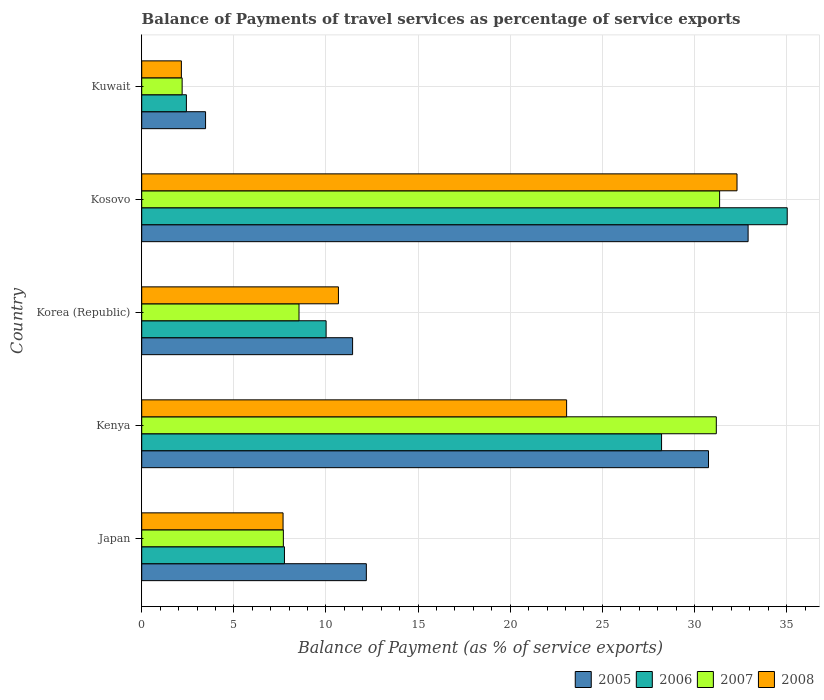How many groups of bars are there?
Offer a very short reply. 5. What is the label of the 2nd group of bars from the top?
Offer a terse response. Kosovo. What is the balance of payments of travel services in 2008 in Korea (Republic)?
Your answer should be compact. 10.68. Across all countries, what is the maximum balance of payments of travel services in 2008?
Offer a very short reply. 32.31. Across all countries, what is the minimum balance of payments of travel services in 2005?
Make the answer very short. 3.46. In which country was the balance of payments of travel services in 2006 maximum?
Offer a terse response. Kosovo. In which country was the balance of payments of travel services in 2005 minimum?
Ensure brevity in your answer.  Kuwait. What is the total balance of payments of travel services in 2006 in the graph?
Your answer should be very brief. 83.42. What is the difference between the balance of payments of travel services in 2008 in Kenya and that in Kuwait?
Your response must be concise. 20.91. What is the difference between the balance of payments of travel services in 2005 in Japan and the balance of payments of travel services in 2006 in Korea (Republic)?
Keep it short and to the point. 2.18. What is the average balance of payments of travel services in 2008 per country?
Provide a short and direct response. 15.17. What is the difference between the balance of payments of travel services in 2006 and balance of payments of travel services in 2005 in Korea (Republic)?
Give a very brief answer. -1.44. In how many countries, is the balance of payments of travel services in 2006 greater than 28 %?
Your answer should be compact. 2. What is the ratio of the balance of payments of travel services in 2006 in Kenya to that in Kuwait?
Offer a terse response. 11.64. Is the difference between the balance of payments of travel services in 2006 in Japan and Kuwait greater than the difference between the balance of payments of travel services in 2005 in Japan and Kuwait?
Offer a terse response. No. What is the difference between the highest and the second highest balance of payments of travel services in 2006?
Give a very brief answer. 6.82. What is the difference between the highest and the lowest balance of payments of travel services in 2005?
Keep it short and to the point. 29.45. Is the sum of the balance of payments of travel services in 2005 in Japan and Kuwait greater than the maximum balance of payments of travel services in 2007 across all countries?
Your answer should be very brief. No. Is it the case that in every country, the sum of the balance of payments of travel services in 2008 and balance of payments of travel services in 2007 is greater than the sum of balance of payments of travel services in 2006 and balance of payments of travel services in 2005?
Your response must be concise. No. Is it the case that in every country, the sum of the balance of payments of travel services in 2005 and balance of payments of travel services in 2006 is greater than the balance of payments of travel services in 2007?
Make the answer very short. Yes. Are all the bars in the graph horizontal?
Offer a terse response. Yes. How many countries are there in the graph?
Offer a terse response. 5. Are the values on the major ticks of X-axis written in scientific E-notation?
Offer a terse response. No. Does the graph contain any zero values?
Your answer should be compact. No. Does the graph contain grids?
Provide a succinct answer. Yes. Where does the legend appear in the graph?
Provide a short and direct response. Bottom right. What is the title of the graph?
Offer a very short reply. Balance of Payments of travel services as percentage of service exports. Does "2001" appear as one of the legend labels in the graph?
Keep it short and to the point. No. What is the label or title of the X-axis?
Your response must be concise. Balance of Payment (as % of service exports). What is the label or title of the Y-axis?
Your answer should be compact. Country. What is the Balance of Payment (as % of service exports) in 2005 in Japan?
Offer a very short reply. 12.19. What is the Balance of Payment (as % of service exports) of 2006 in Japan?
Your answer should be very brief. 7.75. What is the Balance of Payment (as % of service exports) of 2007 in Japan?
Ensure brevity in your answer.  7.69. What is the Balance of Payment (as % of service exports) of 2008 in Japan?
Give a very brief answer. 7.67. What is the Balance of Payment (as % of service exports) in 2005 in Kenya?
Make the answer very short. 30.76. What is the Balance of Payment (as % of service exports) of 2006 in Kenya?
Ensure brevity in your answer.  28.21. What is the Balance of Payment (as % of service exports) in 2007 in Kenya?
Make the answer very short. 31.18. What is the Balance of Payment (as % of service exports) of 2008 in Kenya?
Ensure brevity in your answer.  23.06. What is the Balance of Payment (as % of service exports) of 2005 in Korea (Republic)?
Provide a short and direct response. 11.44. What is the Balance of Payment (as % of service exports) in 2006 in Korea (Republic)?
Make the answer very short. 10.01. What is the Balance of Payment (as % of service exports) in 2007 in Korea (Republic)?
Provide a short and direct response. 8.54. What is the Balance of Payment (as % of service exports) of 2008 in Korea (Republic)?
Make the answer very short. 10.68. What is the Balance of Payment (as % of service exports) of 2005 in Kosovo?
Provide a short and direct response. 32.91. What is the Balance of Payment (as % of service exports) of 2006 in Kosovo?
Provide a short and direct response. 35.03. What is the Balance of Payment (as % of service exports) in 2007 in Kosovo?
Provide a short and direct response. 31.36. What is the Balance of Payment (as % of service exports) of 2008 in Kosovo?
Provide a succinct answer. 32.31. What is the Balance of Payment (as % of service exports) of 2005 in Kuwait?
Your answer should be very brief. 3.46. What is the Balance of Payment (as % of service exports) of 2006 in Kuwait?
Ensure brevity in your answer.  2.42. What is the Balance of Payment (as % of service exports) in 2007 in Kuwait?
Your answer should be compact. 2.19. What is the Balance of Payment (as % of service exports) in 2008 in Kuwait?
Your answer should be very brief. 2.15. Across all countries, what is the maximum Balance of Payment (as % of service exports) in 2005?
Your response must be concise. 32.91. Across all countries, what is the maximum Balance of Payment (as % of service exports) in 2006?
Offer a terse response. 35.03. Across all countries, what is the maximum Balance of Payment (as % of service exports) of 2007?
Make the answer very short. 31.36. Across all countries, what is the maximum Balance of Payment (as % of service exports) of 2008?
Offer a terse response. 32.31. Across all countries, what is the minimum Balance of Payment (as % of service exports) in 2005?
Keep it short and to the point. 3.46. Across all countries, what is the minimum Balance of Payment (as % of service exports) in 2006?
Provide a succinct answer. 2.42. Across all countries, what is the minimum Balance of Payment (as % of service exports) of 2007?
Offer a terse response. 2.19. Across all countries, what is the minimum Balance of Payment (as % of service exports) in 2008?
Offer a terse response. 2.15. What is the total Balance of Payment (as % of service exports) of 2005 in the graph?
Your answer should be very brief. 90.77. What is the total Balance of Payment (as % of service exports) of 2006 in the graph?
Offer a terse response. 83.42. What is the total Balance of Payment (as % of service exports) of 2007 in the graph?
Provide a succinct answer. 80.96. What is the total Balance of Payment (as % of service exports) in 2008 in the graph?
Your answer should be compact. 75.87. What is the difference between the Balance of Payment (as % of service exports) of 2005 in Japan and that in Kenya?
Offer a terse response. -18.57. What is the difference between the Balance of Payment (as % of service exports) of 2006 in Japan and that in Kenya?
Provide a succinct answer. -20.47. What is the difference between the Balance of Payment (as % of service exports) of 2007 in Japan and that in Kenya?
Offer a terse response. -23.5. What is the difference between the Balance of Payment (as % of service exports) in 2008 in Japan and that in Kenya?
Offer a very short reply. -15.39. What is the difference between the Balance of Payment (as % of service exports) in 2005 in Japan and that in Korea (Republic)?
Offer a very short reply. 0.75. What is the difference between the Balance of Payment (as % of service exports) of 2006 in Japan and that in Korea (Republic)?
Keep it short and to the point. -2.26. What is the difference between the Balance of Payment (as % of service exports) in 2007 in Japan and that in Korea (Republic)?
Your answer should be very brief. -0.85. What is the difference between the Balance of Payment (as % of service exports) in 2008 in Japan and that in Korea (Republic)?
Offer a terse response. -3. What is the difference between the Balance of Payment (as % of service exports) in 2005 in Japan and that in Kosovo?
Your answer should be compact. -20.72. What is the difference between the Balance of Payment (as % of service exports) in 2006 in Japan and that in Kosovo?
Keep it short and to the point. -27.29. What is the difference between the Balance of Payment (as % of service exports) in 2007 in Japan and that in Kosovo?
Provide a succinct answer. -23.68. What is the difference between the Balance of Payment (as % of service exports) in 2008 in Japan and that in Kosovo?
Make the answer very short. -24.64. What is the difference between the Balance of Payment (as % of service exports) in 2005 in Japan and that in Kuwait?
Keep it short and to the point. 8.73. What is the difference between the Balance of Payment (as % of service exports) of 2006 in Japan and that in Kuwait?
Make the answer very short. 5.32. What is the difference between the Balance of Payment (as % of service exports) in 2007 in Japan and that in Kuwait?
Your answer should be very brief. 5.49. What is the difference between the Balance of Payment (as % of service exports) in 2008 in Japan and that in Kuwait?
Provide a short and direct response. 5.52. What is the difference between the Balance of Payment (as % of service exports) of 2005 in Kenya and that in Korea (Republic)?
Your response must be concise. 19.32. What is the difference between the Balance of Payment (as % of service exports) in 2006 in Kenya and that in Korea (Republic)?
Keep it short and to the point. 18.21. What is the difference between the Balance of Payment (as % of service exports) of 2007 in Kenya and that in Korea (Republic)?
Your answer should be very brief. 22.65. What is the difference between the Balance of Payment (as % of service exports) in 2008 in Kenya and that in Korea (Republic)?
Give a very brief answer. 12.38. What is the difference between the Balance of Payment (as % of service exports) in 2005 in Kenya and that in Kosovo?
Your response must be concise. -2.15. What is the difference between the Balance of Payment (as % of service exports) in 2006 in Kenya and that in Kosovo?
Your response must be concise. -6.82. What is the difference between the Balance of Payment (as % of service exports) of 2007 in Kenya and that in Kosovo?
Provide a short and direct response. -0.18. What is the difference between the Balance of Payment (as % of service exports) in 2008 in Kenya and that in Kosovo?
Offer a very short reply. -9.25. What is the difference between the Balance of Payment (as % of service exports) in 2005 in Kenya and that in Kuwait?
Provide a short and direct response. 27.3. What is the difference between the Balance of Payment (as % of service exports) in 2006 in Kenya and that in Kuwait?
Ensure brevity in your answer.  25.79. What is the difference between the Balance of Payment (as % of service exports) of 2007 in Kenya and that in Kuwait?
Your answer should be compact. 28.99. What is the difference between the Balance of Payment (as % of service exports) in 2008 in Kenya and that in Kuwait?
Your answer should be very brief. 20.91. What is the difference between the Balance of Payment (as % of service exports) in 2005 in Korea (Republic) and that in Kosovo?
Keep it short and to the point. -21.47. What is the difference between the Balance of Payment (as % of service exports) of 2006 in Korea (Republic) and that in Kosovo?
Give a very brief answer. -25.03. What is the difference between the Balance of Payment (as % of service exports) of 2007 in Korea (Republic) and that in Kosovo?
Your answer should be very brief. -22.83. What is the difference between the Balance of Payment (as % of service exports) in 2008 in Korea (Republic) and that in Kosovo?
Provide a succinct answer. -21.63. What is the difference between the Balance of Payment (as % of service exports) of 2005 in Korea (Republic) and that in Kuwait?
Keep it short and to the point. 7.98. What is the difference between the Balance of Payment (as % of service exports) in 2006 in Korea (Republic) and that in Kuwait?
Your answer should be very brief. 7.58. What is the difference between the Balance of Payment (as % of service exports) of 2007 in Korea (Republic) and that in Kuwait?
Provide a short and direct response. 6.34. What is the difference between the Balance of Payment (as % of service exports) in 2008 in Korea (Republic) and that in Kuwait?
Provide a succinct answer. 8.52. What is the difference between the Balance of Payment (as % of service exports) of 2005 in Kosovo and that in Kuwait?
Ensure brevity in your answer.  29.45. What is the difference between the Balance of Payment (as % of service exports) of 2006 in Kosovo and that in Kuwait?
Give a very brief answer. 32.61. What is the difference between the Balance of Payment (as % of service exports) of 2007 in Kosovo and that in Kuwait?
Make the answer very short. 29.17. What is the difference between the Balance of Payment (as % of service exports) in 2008 in Kosovo and that in Kuwait?
Offer a very short reply. 30.16. What is the difference between the Balance of Payment (as % of service exports) in 2005 in Japan and the Balance of Payment (as % of service exports) in 2006 in Kenya?
Your answer should be compact. -16.02. What is the difference between the Balance of Payment (as % of service exports) in 2005 in Japan and the Balance of Payment (as % of service exports) in 2007 in Kenya?
Your answer should be very brief. -18.99. What is the difference between the Balance of Payment (as % of service exports) of 2005 in Japan and the Balance of Payment (as % of service exports) of 2008 in Kenya?
Provide a short and direct response. -10.87. What is the difference between the Balance of Payment (as % of service exports) in 2006 in Japan and the Balance of Payment (as % of service exports) in 2007 in Kenya?
Your answer should be very brief. -23.44. What is the difference between the Balance of Payment (as % of service exports) in 2006 in Japan and the Balance of Payment (as % of service exports) in 2008 in Kenya?
Provide a short and direct response. -15.31. What is the difference between the Balance of Payment (as % of service exports) of 2007 in Japan and the Balance of Payment (as % of service exports) of 2008 in Kenya?
Your answer should be very brief. -15.37. What is the difference between the Balance of Payment (as % of service exports) of 2005 in Japan and the Balance of Payment (as % of service exports) of 2006 in Korea (Republic)?
Offer a very short reply. 2.18. What is the difference between the Balance of Payment (as % of service exports) of 2005 in Japan and the Balance of Payment (as % of service exports) of 2007 in Korea (Republic)?
Offer a terse response. 3.65. What is the difference between the Balance of Payment (as % of service exports) of 2005 in Japan and the Balance of Payment (as % of service exports) of 2008 in Korea (Republic)?
Your answer should be compact. 1.52. What is the difference between the Balance of Payment (as % of service exports) in 2006 in Japan and the Balance of Payment (as % of service exports) in 2007 in Korea (Republic)?
Keep it short and to the point. -0.79. What is the difference between the Balance of Payment (as % of service exports) of 2006 in Japan and the Balance of Payment (as % of service exports) of 2008 in Korea (Republic)?
Give a very brief answer. -2.93. What is the difference between the Balance of Payment (as % of service exports) in 2007 in Japan and the Balance of Payment (as % of service exports) in 2008 in Korea (Republic)?
Your response must be concise. -2.99. What is the difference between the Balance of Payment (as % of service exports) of 2005 in Japan and the Balance of Payment (as % of service exports) of 2006 in Kosovo?
Your answer should be very brief. -22.84. What is the difference between the Balance of Payment (as % of service exports) of 2005 in Japan and the Balance of Payment (as % of service exports) of 2007 in Kosovo?
Your answer should be compact. -19.17. What is the difference between the Balance of Payment (as % of service exports) in 2005 in Japan and the Balance of Payment (as % of service exports) in 2008 in Kosovo?
Offer a terse response. -20.12. What is the difference between the Balance of Payment (as % of service exports) of 2006 in Japan and the Balance of Payment (as % of service exports) of 2007 in Kosovo?
Your answer should be compact. -23.62. What is the difference between the Balance of Payment (as % of service exports) in 2006 in Japan and the Balance of Payment (as % of service exports) in 2008 in Kosovo?
Provide a succinct answer. -24.56. What is the difference between the Balance of Payment (as % of service exports) of 2007 in Japan and the Balance of Payment (as % of service exports) of 2008 in Kosovo?
Keep it short and to the point. -24.62. What is the difference between the Balance of Payment (as % of service exports) in 2005 in Japan and the Balance of Payment (as % of service exports) in 2006 in Kuwait?
Keep it short and to the point. 9.77. What is the difference between the Balance of Payment (as % of service exports) in 2005 in Japan and the Balance of Payment (as % of service exports) in 2007 in Kuwait?
Make the answer very short. 10. What is the difference between the Balance of Payment (as % of service exports) of 2005 in Japan and the Balance of Payment (as % of service exports) of 2008 in Kuwait?
Offer a very short reply. 10.04. What is the difference between the Balance of Payment (as % of service exports) of 2006 in Japan and the Balance of Payment (as % of service exports) of 2007 in Kuwait?
Give a very brief answer. 5.55. What is the difference between the Balance of Payment (as % of service exports) of 2006 in Japan and the Balance of Payment (as % of service exports) of 2008 in Kuwait?
Your answer should be compact. 5.59. What is the difference between the Balance of Payment (as % of service exports) of 2007 in Japan and the Balance of Payment (as % of service exports) of 2008 in Kuwait?
Your answer should be compact. 5.53. What is the difference between the Balance of Payment (as % of service exports) of 2005 in Kenya and the Balance of Payment (as % of service exports) of 2006 in Korea (Republic)?
Provide a succinct answer. 20.75. What is the difference between the Balance of Payment (as % of service exports) of 2005 in Kenya and the Balance of Payment (as % of service exports) of 2007 in Korea (Republic)?
Your answer should be compact. 22.22. What is the difference between the Balance of Payment (as % of service exports) in 2005 in Kenya and the Balance of Payment (as % of service exports) in 2008 in Korea (Republic)?
Make the answer very short. 20.08. What is the difference between the Balance of Payment (as % of service exports) in 2006 in Kenya and the Balance of Payment (as % of service exports) in 2007 in Korea (Republic)?
Offer a terse response. 19.68. What is the difference between the Balance of Payment (as % of service exports) in 2006 in Kenya and the Balance of Payment (as % of service exports) in 2008 in Korea (Republic)?
Provide a succinct answer. 17.54. What is the difference between the Balance of Payment (as % of service exports) of 2007 in Kenya and the Balance of Payment (as % of service exports) of 2008 in Korea (Republic)?
Ensure brevity in your answer.  20.51. What is the difference between the Balance of Payment (as % of service exports) of 2005 in Kenya and the Balance of Payment (as % of service exports) of 2006 in Kosovo?
Provide a short and direct response. -4.27. What is the difference between the Balance of Payment (as % of service exports) in 2005 in Kenya and the Balance of Payment (as % of service exports) in 2007 in Kosovo?
Keep it short and to the point. -0.6. What is the difference between the Balance of Payment (as % of service exports) of 2005 in Kenya and the Balance of Payment (as % of service exports) of 2008 in Kosovo?
Make the answer very short. -1.55. What is the difference between the Balance of Payment (as % of service exports) of 2006 in Kenya and the Balance of Payment (as % of service exports) of 2007 in Kosovo?
Your answer should be compact. -3.15. What is the difference between the Balance of Payment (as % of service exports) in 2006 in Kenya and the Balance of Payment (as % of service exports) in 2008 in Kosovo?
Provide a short and direct response. -4.09. What is the difference between the Balance of Payment (as % of service exports) in 2007 in Kenya and the Balance of Payment (as % of service exports) in 2008 in Kosovo?
Your answer should be very brief. -1.12. What is the difference between the Balance of Payment (as % of service exports) in 2005 in Kenya and the Balance of Payment (as % of service exports) in 2006 in Kuwait?
Ensure brevity in your answer.  28.34. What is the difference between the Balance of Payment (as % of service exports) of 2005 in Kenya and the Balance of Payment (as % of service exports) of 2007 in Kuwait?
Keep it short and to the point. 28.57. What is the difference between the Balance of Payment (as % of service exports) in 2005 in Kenya and the Balance of Payment (as % of service exports) in 2008 in Kuwait?
Offer a terse response. 28.61. What is the difference between the Balance of Payment (as % of service exports) in 2006 in Kenya and the Balance of Payment (as % of service exports) in 2007 in Kuwait?
Give a very brief answer. 26.02. What is the difference between the Balance of Payment (as % of service exports) in 2006 in Kenya and the Balance of Payment (as % of service exports) in 2008 in Kuwait?
Your answer should be compact. 26.06. What is the difference between the Balance of Payment (as % of service exports) of 2007 in Kenya and the Balance of Payment (as % of service exports) of 2008 in Kuwait?
Provide a succinct answer. 29.03. What is the difference between the Balance of Payment (as % of service exports) in 2005 in Korea (Republic) and the Balance of Payment (as % of service exports) in 2006 in Kosovo?
Offer a very short reply. -23.59. What is the difference between the Balance of Payment (as % of service exports) of 2005 in Korea (Republic) and the Balance of Payment (as % of service exports) of 2007 in Kosovo?
Give a very brief answer. -19.92. What is the difference between the Balance of Payment (as % of service exports) in 2005 in Korea (Republic) and the Balance of Payment (as % of service exports) in 2008 in Kosovo?
Your answer should be very brief. -20.86. What is the difference between the Balance of Payment (as % of service exports) of 2006 in Korea (Republic) and the Balance of Payment (as % of service exports) of 2007 in Kosovo?
Make the answer very short. -21.36. What is the difference between the Balance of Payment (as % of service exports) in 2006 in Korea (Republic) and the Balance of Payment (as % of service exports) in 2008 in Kosovo?
Provide a succinct answer. -22.3. What is the difference between the Balance of Payment (as % of service exports) in 2007 in Korea (Republic) and the Balance of Payment (as % of service exports) in 2008 in Kosovo?
Give a very brief answer. -23.77. What is the difference between the Balance of Payment (as % of service exports) of 2005 in Korea (Republic) and the Balance of Payment (as % of service exports) of 2006 in Kuwait?
Offer a very short reply. 9.02. What is the difference between the Balance of Payment (as % of service exports) in 2005 in Korea (Republic) and the Balance of Payment (as % of service exports) in 2007 in Kuwait?
Your answer should be compact. 9.25. What is the difference between the Balance of Payment (as % of service exports) of 2005 in Korea (Republic) and the Balance of Payment (as % of service exports) of 2008 in Kuwait?
Your answer should be compact. 9.29. What is the difference between the Balance of Payment (as % of service exports) of 2006 in Korea (Republic) and the Balance of Payment (as % of service exports) of 2007 in Kuwait?
Your answer should be compact. 7.81. What is the difference between the Balance of Payment (as % of service exports) in 2006 in Korea (Republic) and the Balance of Payment (as % of service exports) in 2008 in Kuwait?
Your response must be concise. 7.85. What is the difference between the Balance of Payment (as % of service exports) in 2007 in Korea (Republic) and the Balance of Payment (as % of service exports) in 2008 in Kuwait?
Give a very brief answer. 6.38. What is the difference between the Balance of Payment (as % of service exports) in 2005 in Kosovo and the Balance of Payment (as % of service exports) in 2006 in Kuwait?
Your response must be concise. 30.49. What is the difference between the Balance of Payment (as % of service exports) in 2005 in Kosovo and the Balance of Payment (as % of service exports) in 2007 in Kuwait?
Give a very brief answer. 30.72. What is the difference between the Balance of Payment (as % of service exports) of 2005 in Kosovo and the Balance of Payment (as % of service exports) of 2008 in Kuwait?
Keep it short and to the point. 30.76. What is the difference between the Balance of Payment (as % of service exports) of 2006 in Kosovo and the Balance of Payment (as % of service exports) of 2007 in Kuwait?
Your response must be concise. 32.84. What is the difference between the Balance of Payment (as % of service exports) in 2006 in Kosovo and the Balance of Payment (as % of service exports) in 2008 in Kuwait?
Provide a short and direct response. 32.88. What is the difference between the Balance of Payment (as % of service exports) in 2007 in Kosovo and the Balance of Payment (as % of service exports) in 2008 in Kuwait?
Your answer should be compact. 29.21. What is the average Balance of Payment (as % of service exports) of 2005 per country?
Provide a short and direct response. 18.15. What is the average Balance of Payment (as % of service exports) in 2006 per country?
Offer a terse response. 16.68. What is the average Balance of Payment (as % of service exports) in 2007 per country?
Make the answer very short. 16.19. What is the average Balance of Payment (as % of service exports) in 2008 per country?
Keep it short and to the point. 15.17. What is the difference between the Balance of Payment (as % of service exports) of 2005 and Balance of Payment (as % of service exports) of 2006 in Japan?
Your answer should be very brief. 4.44. What is the difference between the Balance of Payment (as % of service exports) in 2005 and Balance of Payment (as % of service exports) in 2007 in Japan?
Your answer should be very brief. 4.5. What is the difference between the Balance of Payment (as % of service exports) in 2005 and Balance of Payment (as % of service exports) in 2008 in Japan?
Keep it short and to the point. 4.52. What is the difference between the Balance of Payment (as % of service exports) of 2006 and Balance of Payment (as % of service exports) of 2007 in Japan?
Keep it short and to the point. 0.06. What is the difference between the Balance of Payment (as % of service exports) of 2006 and Balance of Payment (as % of service exports) of 2008 in Japan?
Offer a terse response. 0.07. What is the difference between the Balance of Payment (as % of service exports) of 2007 and Balance of Payment (as % of service exports) of 2008 in Japan?
Provide a short and direct response. 0.02. What is the difference between the Balance of Payment (as % of service exports) in 2005 and Balance of Payment (as % of service exports) in 2006 in Kenya?
Provide a succinct answer. 2.55. What is the difference between the Balance of Payment (as % of service exports) in 2005 and Balance of Payment (as % of service exports) in 2007 in Kenya?
Your answer should be compact. -0.42. What is the difference between the Balance of Payment (as % of service exports) of 2005 and Balance of Payment (as % of service exports) of 2008 in Kenya?
Your answer should be compact. 7.7. What is the difference between the Balance of Payment (as % of service exports) in 2006 and Balance of Payment (as % of service exports) in 2007 in Kenya?
Offer a terse response. -2.97. What is the difference between the Balance of Payment (as % of service exports) of 2006 and Balance of Payment (as % of service exports) of 2008 in Kenya?
Your answer should be very brief. 5.15. What is the difference between the Balance of Payment (as % of service exports) of 2007 and Balance of Payment (as % of service exports) of 2008 in Kenya?
Offer a terse response. 8.12. What is the difference between the Balance of Payment (as % of service exports) of 2005 and Balance of Payment (as % of service exports) of 2006 in Korea (Republic)?
Your answer should be compact. 1.44. What is the difference between the Balance of Payment (as % of service exports) in 2005 and Balance of Payment (as % of service exports) in 2007 in Korea (Republic)?
Your answer should be very brief. 2.91. What is the difference between the Balance of Payment (as % of service exports) of 2005 and Balance of Payment (as % of service exports) of 2008 in Korea (Republic)?
Your answer should be compact. 0.77. What is the difference between the Balance of Payment (as % of service exports) of 2006 and Balance of Payment (as % of service exports) of 2007 in Korea (Republic)?
Ensure brevity in your answer.  1.47. What is the difference between the Balance of Payment (as % of service exports) in 2006 and Balance of Payment (as % of service exports) in 2008 in Korea (Republic)?
Keep it short and to the point. -0.67. What is the difference between the Balance of Payment (as % of service exports) of 2007 and Balance of Payment (as % of service exports) of 2008 in Korea (Republic)?
Offer a very short reply. -2.14. What is the difference between the Balance of Payment (as % of service exports) in 2005 and Balance of Payment (as % of service exports) in 2006 in Kosovo?
Provide a succinct answer. -2.12. What is the difference between the Balance of Payment (as % of service exports) of 2005 and Balance of Payment (as % of service exports) of 2007 in Kosovo?
Your answer should be compact. 1.55. What is the difference between the Balance of Payment (as % of service exports) in 2005 and Balance of Payment (as % of service exports) in 2008 in Kosovo?
Provide a short and direct response. 0.6. What is the difference between the Balance of Payment (as % of service exports) of 2006 and Balance of Payment (as % of service exports) of 2007 in Kosovo?
Offer a very short reply. 3.67. What is the difference between the Balance of Payment (as % of service exports) in 2006 and Balance of Payment (as % of service exports) in 2008 in Kosovo?
Ensure brevity in your answer.  2.72. What is the difference between the Balance of Payment (as % of service exports) in 2007 and Balance of Payment (as % of service exports) in 2008 in Kosovo?
Make the answer very short. -0.94. What is the difference between the Balance of Payment (as % of service exports) in 2005 and Balance of Payment (as % of service exports) in 2006 in Kuwait?
Offer a very short reply. 1.04. What is the difference between the Balance of Payment (as % of service exports) of 2005 and Balance of Payment (as % of service exports) of 2007 in Kuwait?
Your answer should be compact. 1.27. What is the difference between the Balance of Payment (as % of service exports) of 2005 and Balance of Payment (as % of service exports) of 2008 in Kuwait?
Offer a terse response. 1.31. What is the difference between the Balance of Payment (as % of service exports) of 2006 and Balance of Payment (as % of service exports) of 2007 in Kuwait?
Your answer should be compact. 0.23. What is the difference between the Balance of Payment (as % of service exports) of 2006 and Balance of Payment (as % of service exports) of 2008 in Kuwait?
Give a very brief answer. 0.27. What is the difference between the Balance of Payment (as % of service exports) of 2007 and Balance of Payment (as % of service exports) of 2008 in Kuwait?
Give a very brief answer. 0.04. What is the ratio of the Balance of Payment (as % of service exports) in 2005 in Japan to that in Kenya?
Your response must be concise. 0.4. What is the ratio of the Balance of Payment (as % of service exports) of 2006 in Japan to that in Kenya?
Ensure brevity in your answer.  0.27. What is the ratio of the Balance of Payment (as % of service exports) of 2007 in Japan to that in Kenya?
Your response must be concise. 0.25. What is the ratio of the Balance of Payment (as % of service exports) in 2008 in Japan to that in Kenya?
Give a very brief answer. 0.33. What is the ratio of the Balance of Payment (as % of service exports) of 2005 in Japan to that in Korea (Republic)?
Ensure brevity in your answer.  1.07. What is the ratio of the Balance of Payment (as % of service exports) of 2006 in Japan to that in Korea (Republic)?
Give a very brief answer. 0.77. What is the ratio of the Balance of Payment (as % of service exports) in 2007 in Japan to that in Korea (Republic)?
Offer a very short reply. 0.9. What is the ratio of the Balance of Payment (as % of service exports) in 2008 in Japan to that in Korea (Republic)?
Provide a succinct answer. 0.72. What is the ratio of the Balance of Payment (as % of service exports) in 2005 in Japan to that in Kosovo?
Give a very brief answer. 0.37. What is the ratio of the Balance of Payment (as % of service exports) of 2006 in Japan to that in Kosovo?
Give a very brief answer. 0.22. What is the ratio of the Balance of Payment (as % of service exports) in 2007 in Japan to that in Kosovo?
Provide a succinct answer. 0.25. What is the ratio of the Balance of Payment (as % of service exports) in 2008 in Japan to that in Kosovo?
Provide a succinct answer. 0.24. What is the ratio of the Balance of Payment (as % of service exports) of 2005 in Japan to that in Kuwait?
Offer a very short reply. 3.52. What is the ratio of the Balance of Payment (as % of service exports) of 2006 in Japan to that in Kuwait?
Your answer should be compact. 3.2. What is the ratio of the Balance of Payment (as % of service exports) in 2007 in Japan to that in Kuwait?
Give a very brief answer. 3.5. What is the ratio of the Balance of Payment (as % of service exports) of 2008 in Japan to that in Kuwait?
Give a very brief answer. 3.56. What is the ratio of the Balance of Payment (as % of service exports) of 2005 in Kenya to that in Korea (Republic)?
Provide a succinct answer. 2.69. What is the ratio of the Balance of Payment (as % of service exports) of 2006 in Kenya to that in Korea (Republic)?
Offer a terse response. 2.82. What is the ratio of the Balance of Payment (as % of service exports) in 2007 in Kenya to that in Korea (Republic)?
Your answer should be very brief. 3.65. What is the ratio of the Balance of Payment (as % of service exports) in 2008 in Kenya to that in Korea (Republic)?
Ensure brevity in your answer.  2.16. What is the ratio of the Balance of Payment (as % of service exports) in 2005 in Kenya to that in Kosovo?
Give a very brief answer. 0.93. What is the ratio of the Balance of Payment (as % of service exports) in 2006 in Kenya to that in Kosovo?
Give a very brief answer. 0.81. What is the ratio of the Balance of Payment (as % of service exports) of 2007 in Kenya to that in Kosovo?
Give a very brief answer. 0.99. What is the ratio of the Balance of Payment (as % of service exports) of 2008 in Kenya to that in Kosovo?
Offer a terse response. 0.71. What is the ratio of the Balance of Payment (as % of service exports) of 2005 in Kenya to that in Kuwait?
Provide a short and direct response. 8.88. What is the ratio of the Balance of Payment (as % of service exports) in 2006 in Kenya to that in Kuwait?
Offer a terse response. 11.64. What is the ratio of the Balance of Payment (as % of service exports) in 2007 in Kenya to that in Kuwait?
Make the answer very short. 14.22. What is the ratio of the Balance of Payment (as % of service exports) of 2008 in Kenya to that in Kuwait?
Offer a terse response. 10.71. What is the ratio of the Balance of Payment (as % of service exports) of 2005 in Korea (Republic) to that in Kosovo?
Your response must be concise. 0.35. What is the ratio of the Balance of Payment (as % of service exports) of 2006 in Korea (Republic) to that in Kosovo?
Provide a succinct answer. 0.29. What is the ratio of the Balance of Payment (as % of service exports) in 2007 in Korea (Republic) to that in Kosovo?
Ensure brevity in your answer.  0.27. What is the ratio of the Balance of Payment (as % of service exports) in 2008 in Korea (Republic) to that in Kosovo?
Give a very brief answer. 0.33. What is the ratio of the Balance of Payment (as % of service exports) of 2005 in Korea (Republic) to that in Kuwait?
Your answer should be compact. 3.3. What is the ratio of the Balance of Payment (as % of service exports) in 2006 in Korea (Republic) to that in Kuwait?
Keep it short and to the point. 4.13. What is the ratio of the Balance of Payment (as % of service exports) in 2007 in Korea (Republic) to that in Kuwait?
Offer a terse response. 3.89. What is the ratio of the Balance of Payment (as % of service exports) in 2008 in Korea (Republic) to that in Kuwait?
Give a very brief answer. 4.96. What is the ratio of the Balance of Payment (as % of service exports) of 2005 in Kosovo to that in Kuwait?
Keep it short and to the point. 9.5. What is the ratio of the Balance of Payment (as % of service exports) of 2006 in Kosovo to that in Kuwait?
Keep it short and to the point. 14.45. What is the ratio of the Balance of Payment (as % of service exports) in 2007 in Kosovo to that in Kuwait?
Your response must be concise. 14.3. What is the ratio of the Balance of Payment (as % of service exports) of 2008 in Kosovo to that in Kuwait?
Ensure brevity in your answer.  15.01. What is the difference between the highest and the second highest Balance of Payment (as % of service exports) in 2005?
Provide a succinct answer. 2.15. What is the difference between the highest and the second highest Balance of Payment (as % of service exports) in 2006?
Your response must be concise. 6.82. What is the difference between the highest and the second highest Balance of Payment (as % of service exports) of 2007?
Make the answer very short. 0.18. What is the difference between the highest and the second highest Balance of Payment (as % of service exports) in 2008?
Your response must be concise. 9.25. What is the difference between the highest and the lowest Balance of Payment (as % of service exports) in 2005?
Your answer should be very brief. 29.45. What is the difference between the highest and the lowest Balance of Payment (as % of service exports) in 2006?
Offer a very short reply. 32.61. What is the difference between the highest and the lowest Balance of Payment (as % of service exports) in 2007?
Provide a succinct answer. 29.17. What is the difference between the highest and the lowest Balance of Payment (as % of service exports) of 2008?
Offer a terse response. 30.16. 